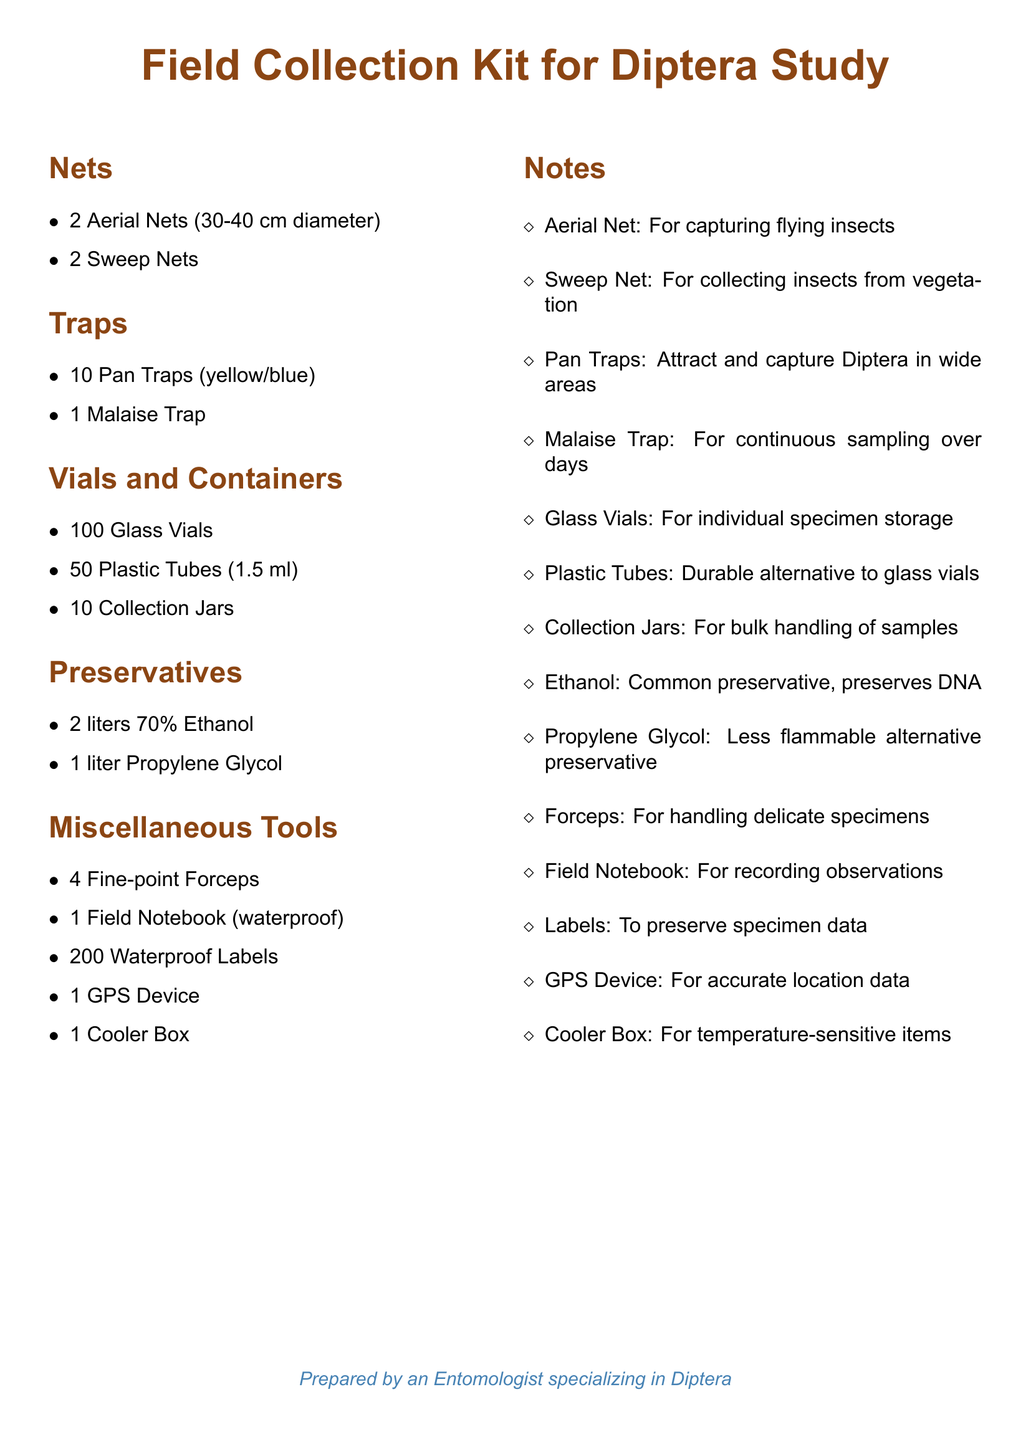what is the diameter of the aerial nets? The diameter for aerial nets is specified in the document as between 30-40 cm.
Answer: 30-40 cm how many pan traps are listed? The number of pan traps is specified in the inventory section, showing there are 10.
Answer: 10 what is the purpose of the malaise trap? The malaise trap is noted in the document for its use in continuous sampling over days.
Answer: Continuous sampling how many glass vials are included in the kit? The document explicitly states that there are 100 glass vials included.
Answer: 100 what alternative to ethanol is mentioned? Propylene glycol is listed as a less flammable alternative preservative in the kit.
Answer: Propylene Glycol which tool is suggested for handling delicate specimens? The document references fine-point forceps as the tool for handling delicate specimens.
Answer: Fine-point Forceps what is the quantity of waterproof labels available? The document indicates there are 200 waterproof labels included.
Answer: 200 how many sweep nets are in the kit? It specifies that there are 2 sweep nets provided for collection.
Answer: 2 what type of notebook is included in the kit? The field notebook is described in the document as being waterproof.
Answer: Waterproof 